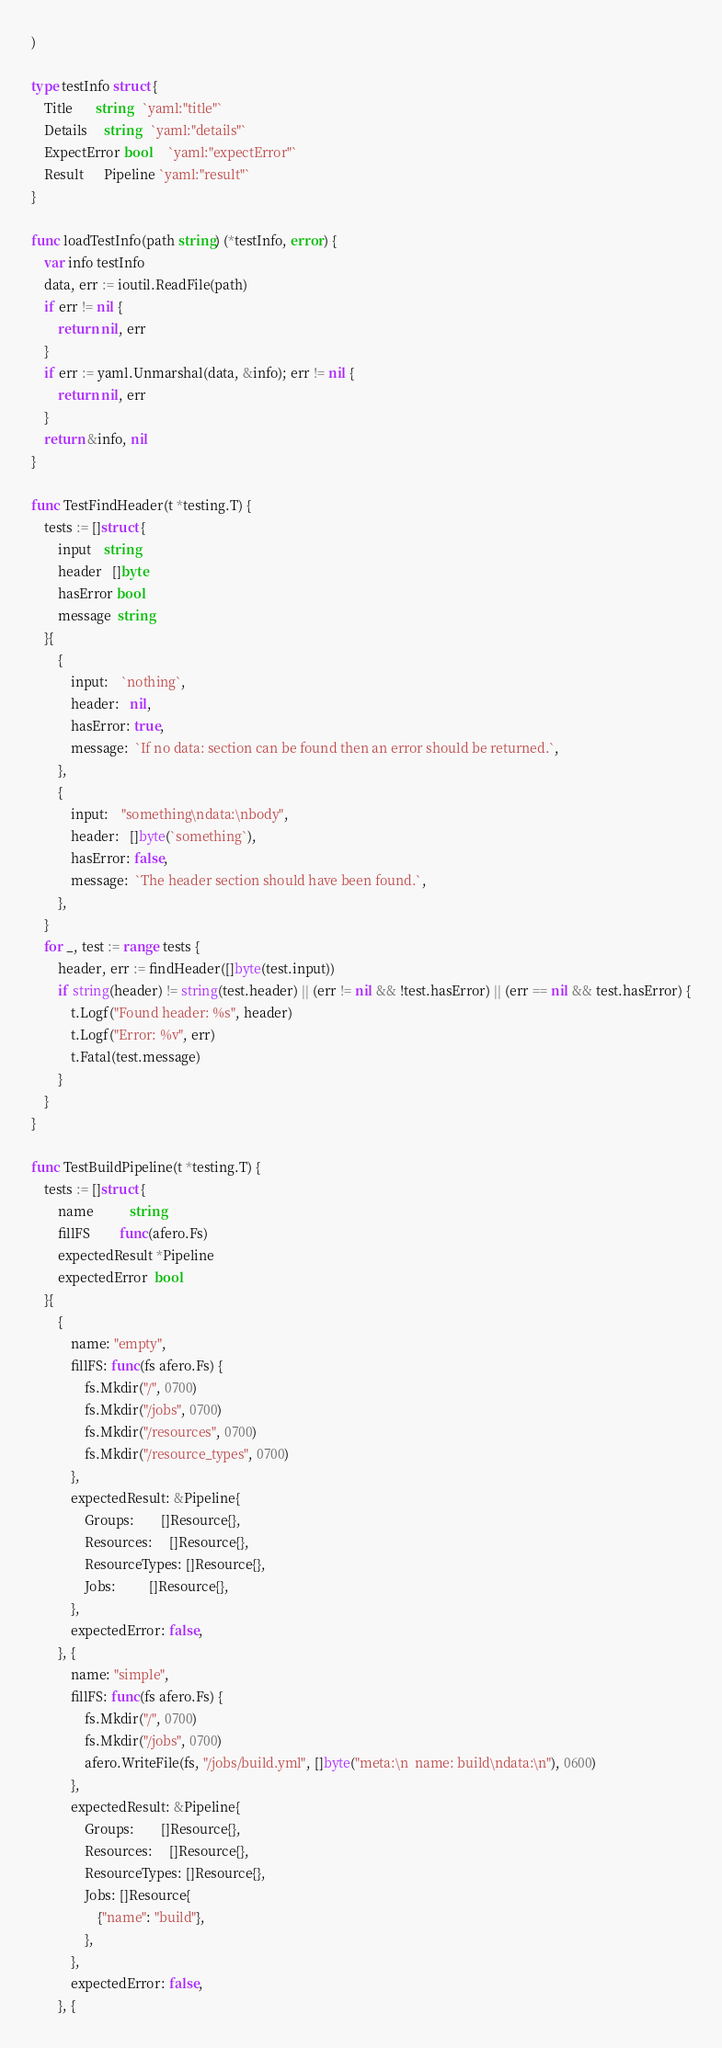<code> <loc_0><loc_0><loc_500><loc_500><_Go_>)

type testInfo struct {
	Title       string   `yaml:"title"`
	Details     string   `yaml:"details"`
	ExpectError bool     `yaml:"expectError"`
	Result      Pipeline `yaml:"result"`
}

func loadTestInfo(path string) (*testInfo, error) {
	var info testInfo
	data, err := ioutil.ReadFile(path)
	if err != nil {
		return nil, err
	}
	if err := yaml.Unmarshal(data, &info); err != nil {
		return nil, err
	}
	return &info, nil
}

func TestFindHeader(t *testing.T) {
	tests := []struct {
		input    string
		header   []byte
		hasError bool
		message  string
	}{
		{
			input:    `nothing`,
			header:   nil,
			hasError: true,
			message:  `If no data: section can be found then an error should be returned.`,
		},
		{
			input:    "something\ndata:\nbody",
			header:   []byte(`something`),
			hasError: false,
			message:  `The header section should have been found.`,
		},
	}
	for _, test := range tests {
		header, err := findHeader([]byte(test.input))
		if string(header) != string(test.header) || (err != nil && !test.hasError) || (err == nil && test.hasError) {
			t.Logf("Found header: %s", header)
			t.Logf("Error: %v", err)
			t.Fatal(test.message)
		}
	}
}

func TestBuildPipeline(t *testing.T) {
	tests := []struct {
		name           string
		fillFS         func(afero.Fs)
		expectedResult *Pipeline
		expectedError  bool
	}{
		{
			name: "empty",
			fillFS: func(fs afero.Fs) {
				fs.Mkdir("/", 0700)
				fs.Mkdir("/jobs", 0700)
				fs.Mkdir("/resources", 0700)
				fs.Mkdir("/resource_types", 0700)
			},
			expectedResult: &Pipeline{
				Groups:        []Resource{},
				Resources:     []Resource{},
				ResourceTypes: []Resource{},
				Jobs:          []Resource{},
			},
			expectedError: false,
		}, {
			name: "simple",
			fillFS: func(fs afero.Fs) {
				fs.Mkdir("/", 0700)
				fs.Mkdir("/jobs", 0700)
				afero.WriteFile(fs, "/jobs/build.yml", []byte("meta:\n  name: build\ndata:\n"), 0600)
			},
			expectedResult: &Pipeline{
				Groups:        []Resource{},
				Resources:     []Resource{},
				ResourceTypes: []Resource{},
				Jobs: []Resource{
					{"name": "build"},
				},
			},
			expectedError: false,
		}, {</code> 